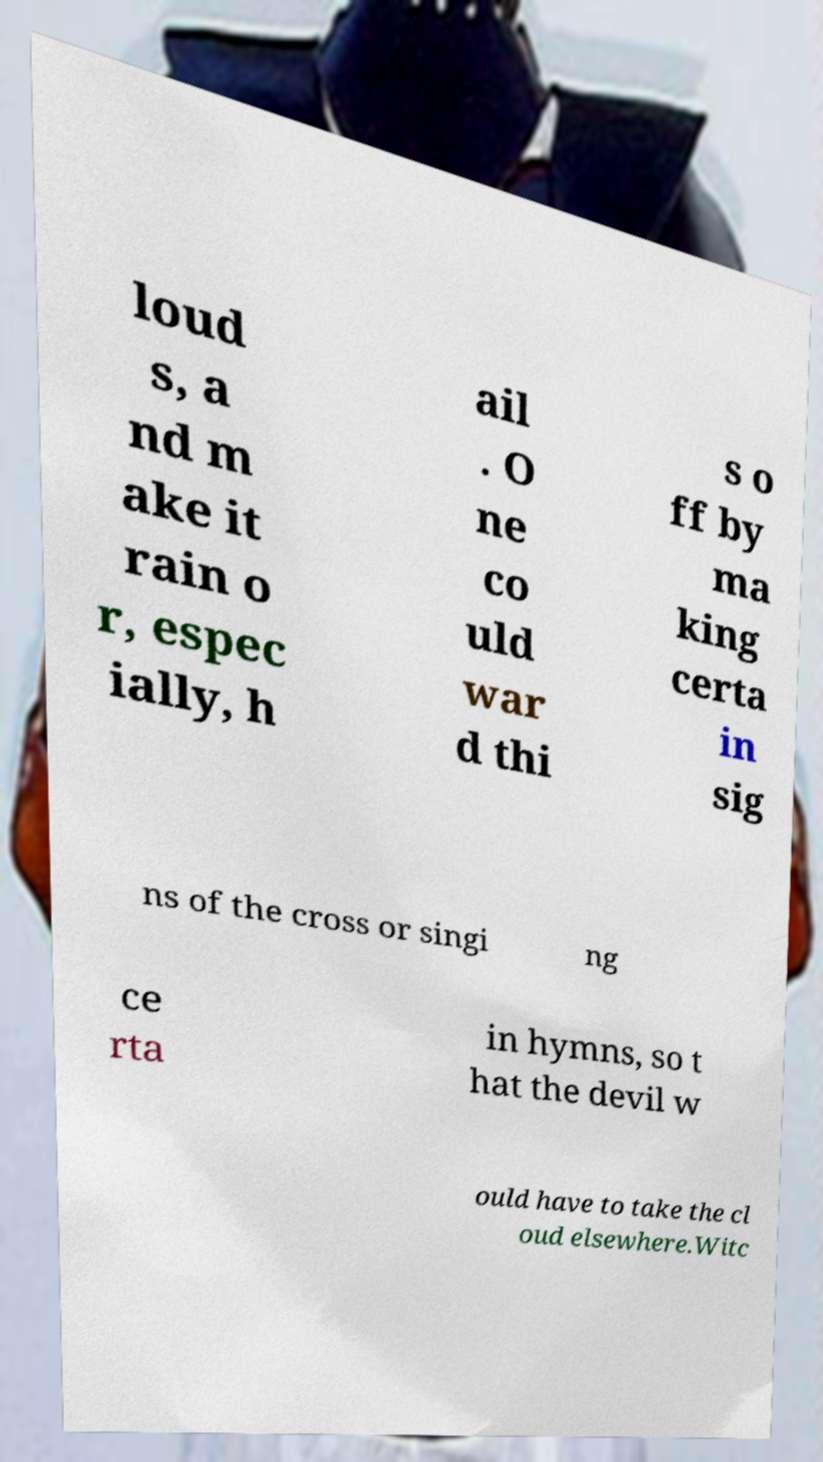There's text embedded in this image that I need extracted. Can you transcribe it verbatim? loud s, a nd m ake it rain o r, espec ially, h ail . O ne co uld war d thi s o ff by ma king certa in sig ns of the cross or singi ng ce rta in hymns, so t hat the devil w ould have to take the cl oud elsewhere.Witc 